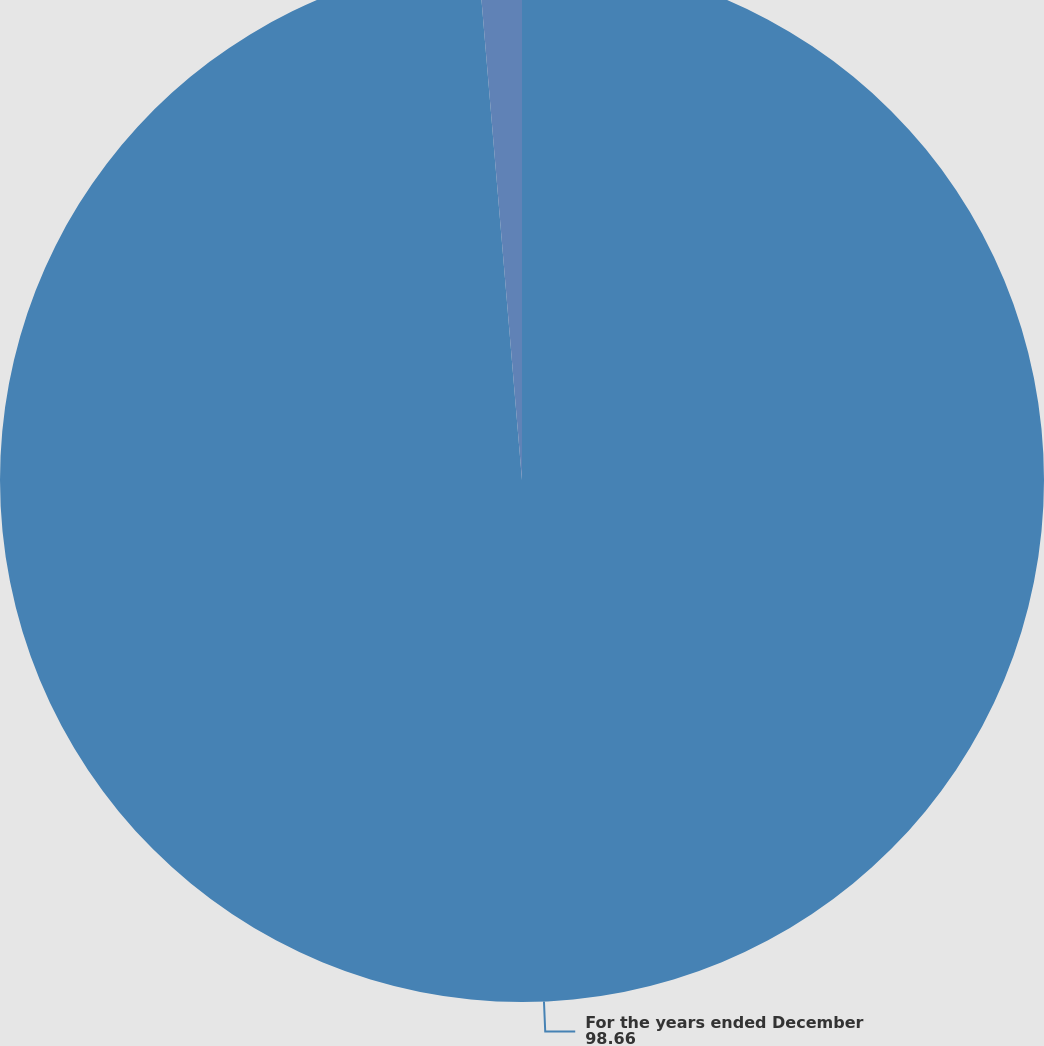Convert chart to OTSL. <chart><loc_0><loc_0><loc_500><loc_500><pie_chart><fcel>For the years ended December<fcel>Compensation amount charged<nl><fcel>98.66%<fcel>1.34%<nl></chart> 